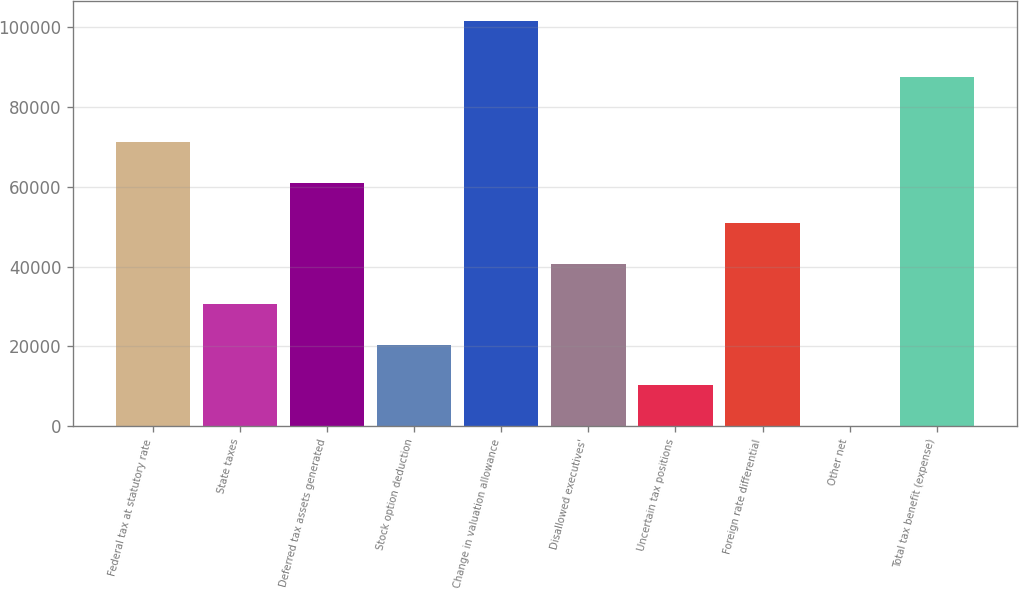Convert chart. <chart><loc_0><loc_0><loc_500><loc_500><bar_chart><fcel>Federal tax at statutory rate<fcel>State taxes<fcel>Deferred tax assets generated<fcel>Stock option deduction<fcel>Change in valuation allowance<fcel>Disallowed executives'<fcel>Uncertain tax positions<fcel>Foreign rate differential<fcel>Other net<fcel>Total tax benefit (expense)<nl><fcel>71124.4<fcel>30539.6<fcel>60978.2<fcel>20393.4<fcel>101563<fcel>40685.8<fcel>10247.2<fcel>50832<fcel>101<fcel>87619<nl></chart> 